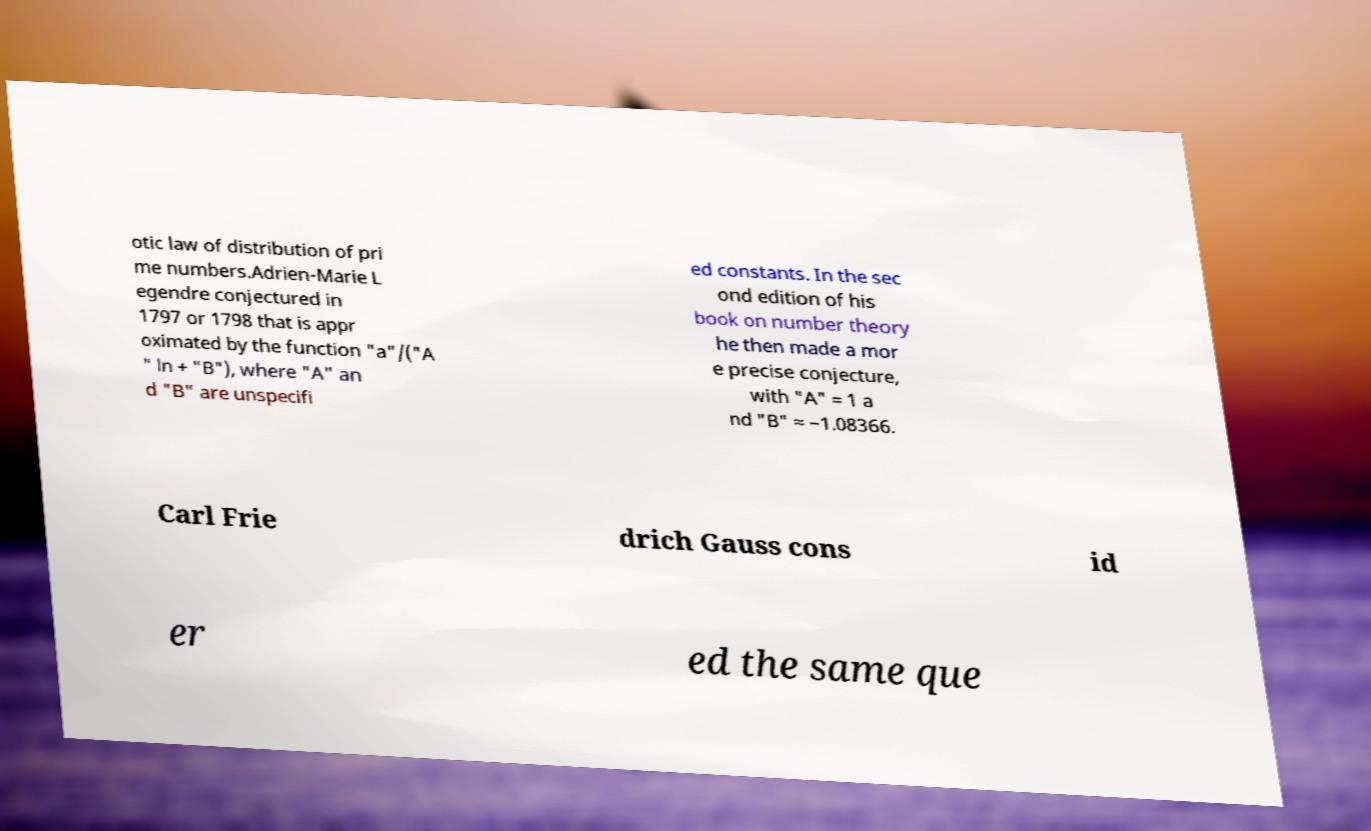Could you assist in decoding the text presented in this image and type it out clearly? otic law of distribution of pri me numbers.Adrien-Marie L egendre conjectured in 1797 or 1798 that is appr oximated by the function "a"/("A " ln + "B"), where "A" an d "B" are unspecifi ed constants. In the sec ond edition of his book on number theory he then made a mor e precise conjecture, with "A" = 1 a nd "B" ≈ −1.08366. Carl Frie drich Gauss cons id er ed the same que 